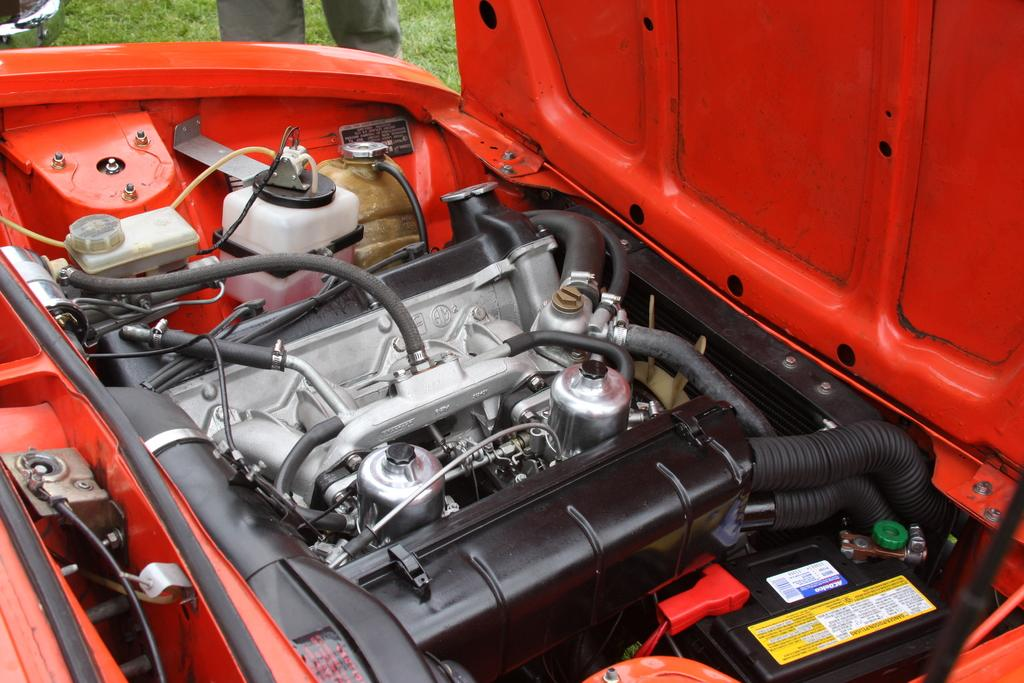What is the main subject of the image? The main subject of the image is the engine of a vehicle. What color is the vehicle? The vehicle is red in color. Can you describe the person in the image? There is a person standing at the top of the image, and they are standing on the ground. What type of vegetation is visible in the image? There is grass visible in the image. How many horses are present in the image? There are no horses present in the image; it features an engine of a vehicle, a red vehicle, a person standing on the ground, and grass. Can you tell me where the bee is located in the image? There is no bee present in the image. 